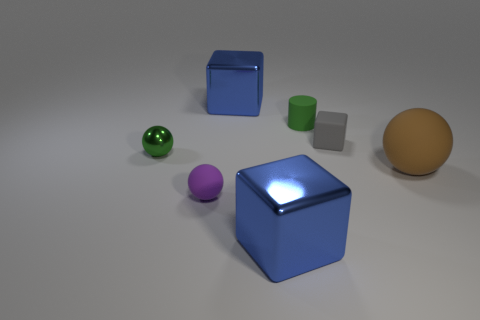Are there any tiny green metallic objects that have the same shape as the small purple thing?
Provide a succinct answer. Yes. There is a large sphere; does it have the same color as the matte sphere left of the brown object?
Offer a very short reply. No. The thing that is the same color as the matte cylinder is what size?
Offer a very short reply. Small. Is there a purple cylinder that has the same size as the brown ball?
Your answer should be compact. No. Is the big ball made of the same material as the green thing that is behind the small green metal ball?
Make the answer very short. Yes. Is the number of big yellow balls greater than the number of tiny balls?
Provide a short and direct response. No. What number of blocks are either big red matte objects or tiny purple rubber objects?
Keep it short and to the point. 0. The small metallic thing is what color?
Provide a short and direct response. Green. Does the rubber thing in front of the brown matte sphere have the same size as the green thing right of the tiny green ball?
Your answer should be compact. Yes. Are there fewer small shiny things than small matte objects?
Make the answer very short. Yes. 